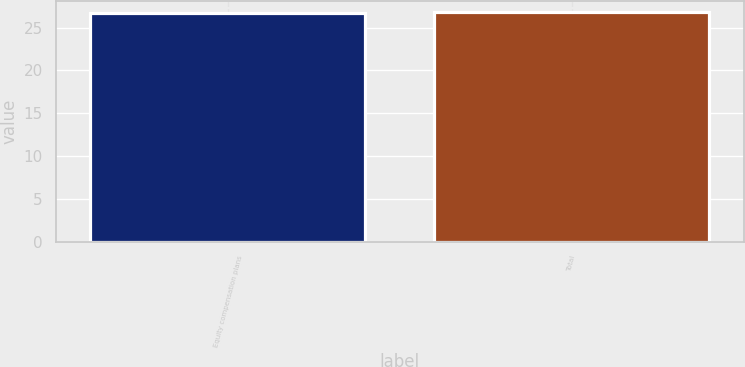Convert chart. <chart><loc_0><loc_0><loc_500><loc_500><bar_chart><fcel>Equity compensation plans<fcel>Total<nl><fcel>26.69<fcel>26.79<nl></chart> 